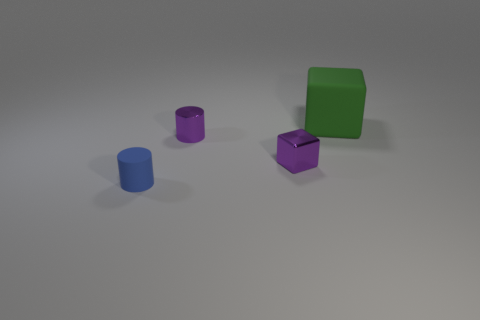Add 3 tiny purple metal cylinders. How many objects exist? 7 Add 1 big matte cubes. How many big matte cubes are left? 2 Add 3 small purple metal objects. How many small purple metal objects exist? 5 Subtract 0 gray cubes. How many objects are left? 4 Subtract all small purple cylinders. Subtract all purple shiny blocks. How many objects are left? 2 